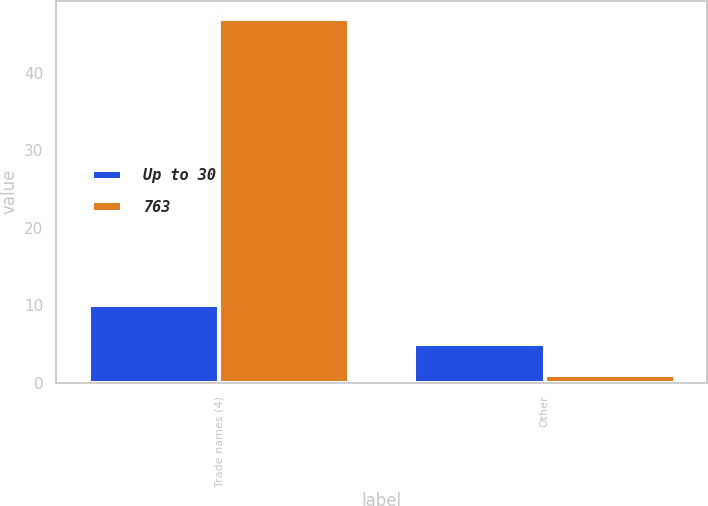Convert chart to OTSL. <chart><loc_0><loc_0><loc_500><loc_500><stacked_bar_chart><ecel><fcel>Trade names (4)<fcel>Other<nl><fcel>Up to 30<fcel>10<fcel>5<nl><fcel>763<fcel>47<fcel>1<nl></chart> 